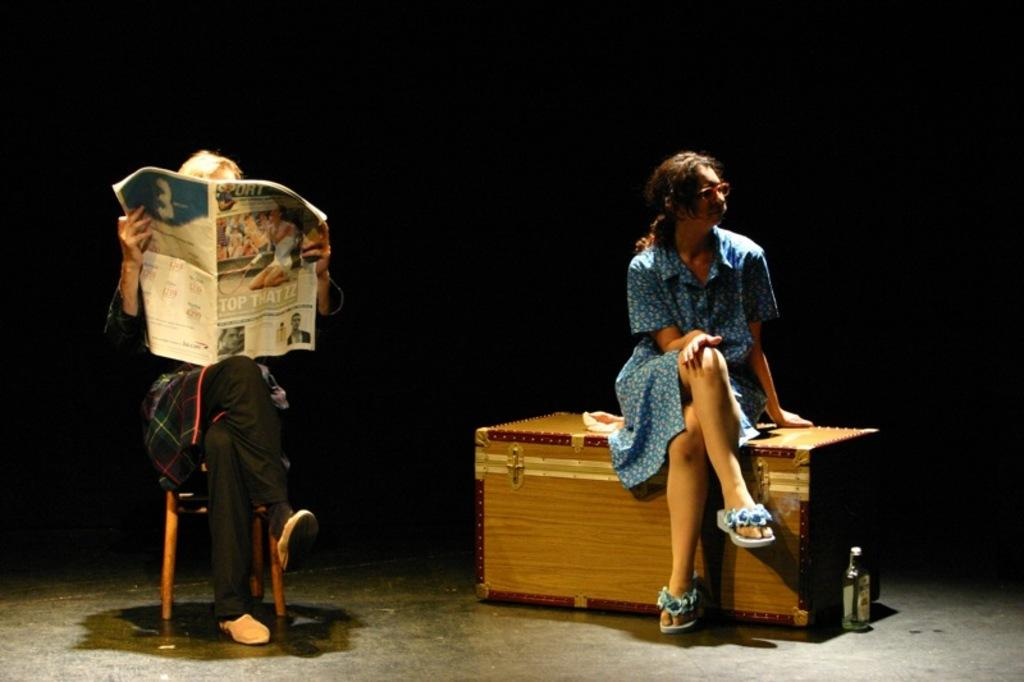What is the woman doing in the image? The woman is sitting on a casket in the image. Which direction is the woman looking? The woman is looking to the right. What is the person in the image doing? The person is sitting on a chair and holding a newspaper. Can you describe the sidewalk in the image? There is no sidewalk present in the image. How does the woman touch the casket in the image? The image does not show the woman touching the casket; she is simply sitting on it. 